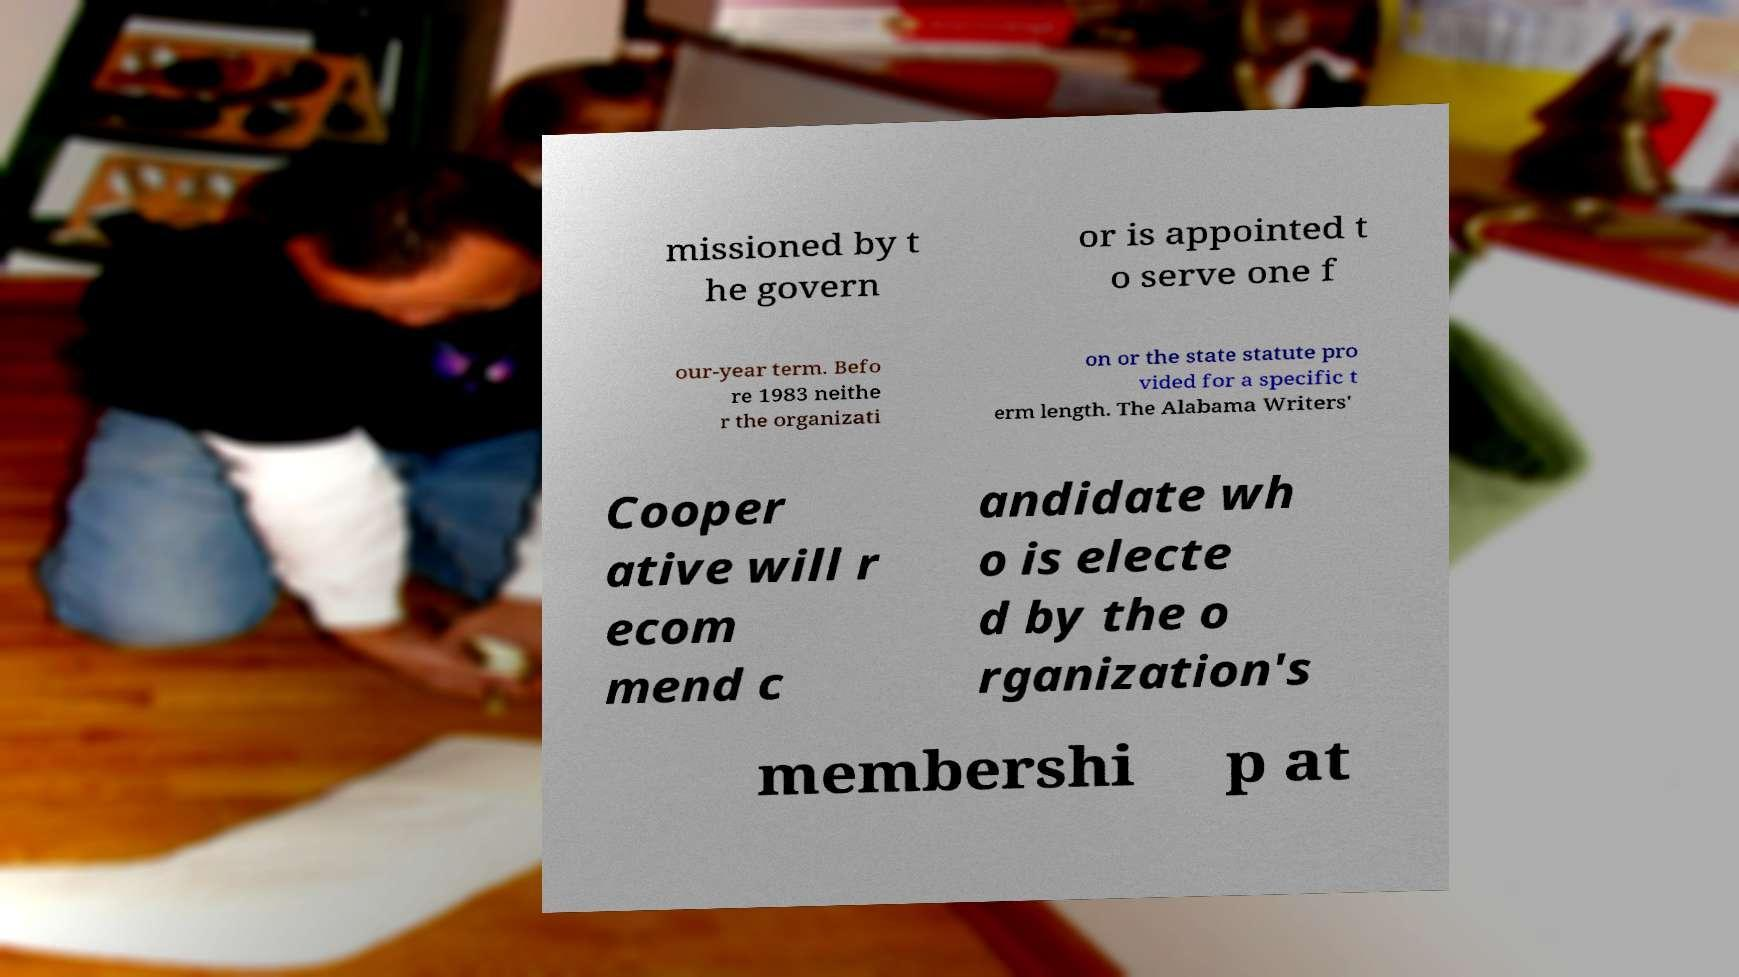What messages or text are displayed in this image? I need them in a readable, typed format. missioned by t he govern or is appointed t o serve one f our-year term. Befo re 1983 neithe r the organizati on or the state statute pro vided for a specific t erm length. The Alabama Writers' Cooper ative will r ecom mend c andidate wh o is electe d by the o rganization's membershi p at 